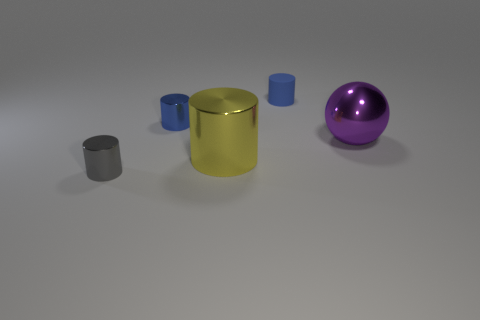Subtract all green balls. How many blue cylinders are left? 2 Subtract all metallic cylinders. How many cylinders are left? 1 Subtract all gray cylinders. How many cylinders are left? 3 Add 4 small gray cylinders. How many objects exist? 9 Subtract all balls. How many objects are left? 4 Subtract all cyan cylinders. Subtract all purple blocks. How many cylinders are left? 4 Subtract 0 red cubes. How many objects are left? 5 Subtract all metal cylinders. Subtract all blue metallic cylinders. How many objects are left? 1 Add 1 purple shiny things. How many purple shiny things are left? 2 Add 5 tiny blue things. How many tiny blue things exist? 7 